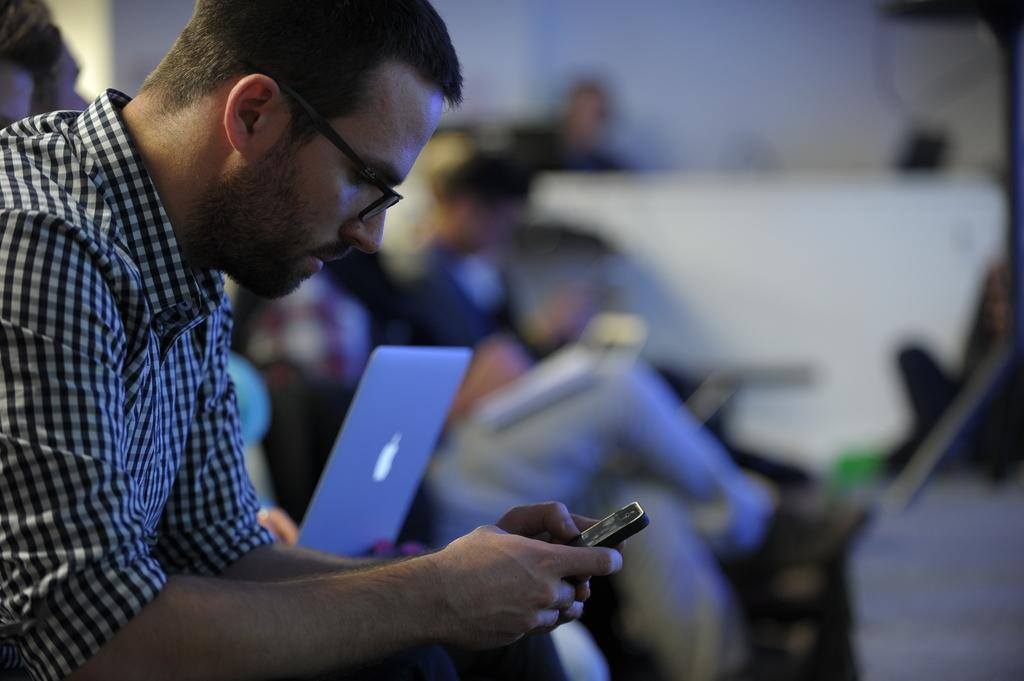What are the people in the image doing? There are persons sitting in the image. Can you describe what one of the persons is holding? A person is holding a mobile in the image. What electronic device is visible in the image? There is a laptop in the image. How does the tiger attempt to pay off its debt in the image? There is no tiger or debt present in the image. 